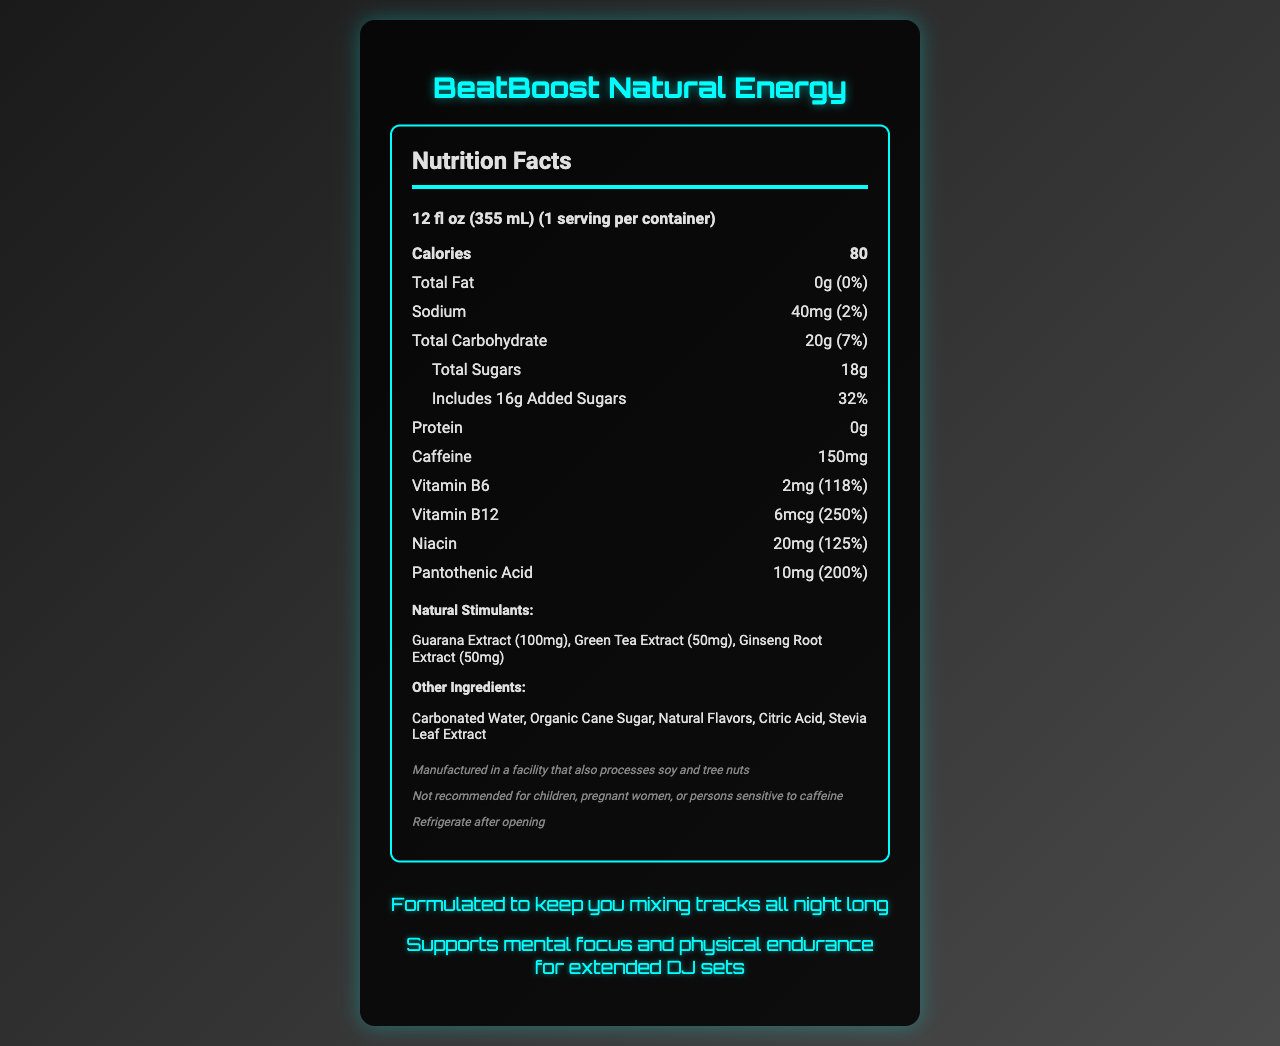what is the serving size of BeatBoost Natural Energy? The serving size is clearly stated at the beginning of the Nutrition Facts section.
Answer: 12 fl oz (355 mL) how many calories are in one serving? The calories are listed in a bold section within the Nutrition Facts.
Answer: 80 how much total fat is in the energy drink? The amount of total fat is listed in the Nutrition Facts and is noted to be 0g.
Answer: 0g what are the sodium and carbohydrate amounts? Both sodium and carbohydrate amounts are given in the Nutritional Facts section on separate lines.
Answer: Sodium: 40mg, Total Carbohydrate: 20g how much caffeine does the drink contain? The caffeine content is specified in the Nutrition Facts section.
Answer: 150mg which vitamins are included in the energy drink and their daily values? The vitamins and their daily values are listed under the vitamins and minerals section.
Answer: Vitamin B6 (118%), Vitamin B12 (250%), Niacin (125%), Pantothenic Acid (200%) how much added sugar is in the energy drink? The added sugars are specified under the total sugars section, with their amount given separately.
Answer: 16g what natural stimulants are listed in BeatBoost Natural Energy? These natural stimulants are clearly listed in a section under Natural Stimulants.
Answer: Guarana Extract (100mg), Green Tea Extract (50mg), Ginseng Root Extract (50mg) which of the following is not an ingredient in BeatBoost Natural Energy? A. Organic Cane Sugar B. Artificial Sweeteners C. Citric Acid The listed ingredients include organic cane sugar and citric acid but do not mention artificial sweeteners.
Answer: B what percentage of the daily value of Pantothenic Acid is in one serving? A. 118% B. 250% C. 125% D. 200% In the vitamins and minerals section, the daily value of Pantothenic Acid is listed as 200%.
Answer: D does the energy drink contain any protein? The amount of protein is given as 0g in the Nutrition Facts.
Answer: No is BeatBoost Natural Energy recommended for children? The disclaimer explicitly states it is not recommended for children.
Answer: No summarize the main features of BeatBoost Natural Energy. This summary captures the nutrition facts, ingredient information, and specific notes targeting DJs.
Answer: BeatBoost Natural Energy is a healthy energy drink designed for DJ performance with natural stimulants. It contains 80 calories per 12 fl oz serving, 0g fat, 40mg sodium, 20g carbohydrates, 18g total sugars (with 16g added sugars), 0g protein, and 150mg caffeine. Vitamins included are Vitamin B6, Vitamin B12, Niacin, and Pantothenic Acid. Natural stimulants are Guarana Extract, Green Tea Extract, and Ginseng Root Extract. Other ingredients include Carbonated Water, Organic Cane Sugar, and Natural Flavors. It is made in a facility processing soy and tree nuts and should be refrigerated after opening. It is targeted towards DJs for mental focus and physical endurance. what is the source of energy in the drink? The source of energy specifically, aside from the calories provided, is not clearly determined from the visual information in the document.
Answer: Not enough information 